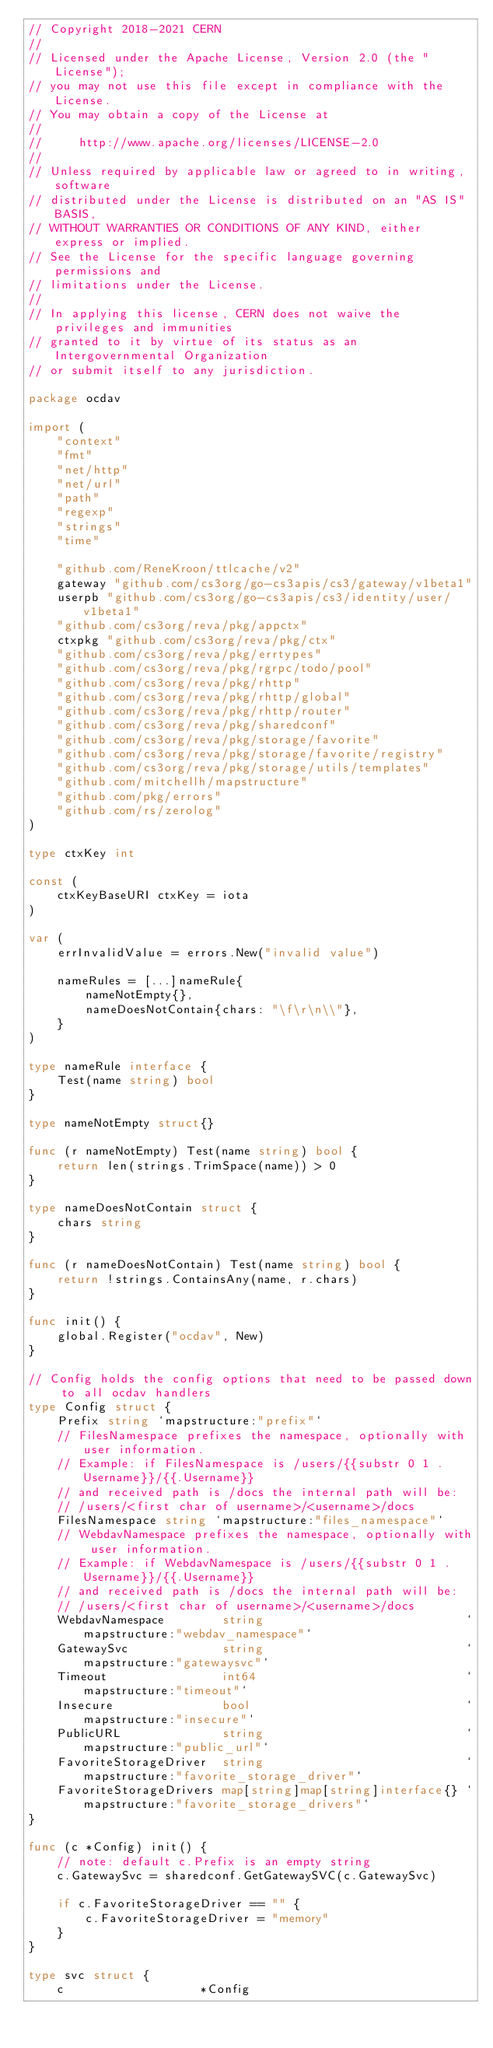<code> <loc_0><loc_0><loc_500><loc_500><_Go_>// Copyright 2018-2021 CERN
//
// Licensed under the Apache License, Version 2.0 (the "License");
// you may not use this file except in compliance with the License.
// You may obtain a copy of the License at
//
//     http://www.apache.org/licenses/LICENSE-2.0
//
// Unless required by applicable law or agreed to in writing, software
// distributed under the License is distributed on an "AS IS" BASIS,
// WITHOUT WARRANTIES OR CONDITIONS OF ANY KIND, either express or implied.
// See the License for the specific language governing permissions and
// limitations under the License.
//
// In applying this license, CERN does not waive the privileges and immunities
// granted to it by virtue of its status as an Intergovernmental Organization
// or submit itself to any jurisdiction.

package ocdav

import (
	"context"
	"fmt"
	"net/http"
	"net/url"
	"path"
	"regexp"
	"strings"
	"time"

	"github.com/ReneKroon/ttlcache/v2"
	gateway "github.com/cs3org/go-cs3apis/cs3/gateway/v1beta1"
	userpb "github.com/cs3org/go-cs3apis/cs3/identity/user/v1beta1"
	"github.com/cs3org/reva/pkg/appctx"
	ctxpkg "github.com/cs3org/reva/pkg/ctx"
	"github.com/cs3org/reva/pkg/errtypes"
	"github.com/cs3org/reva/pkg/rgrpc/todo/pool"
	"github.com/cs3org/reva/pkg/rhttp"
	"github.com/cs3org/reva/pkg/rhttp/global"
	"github.com/cs3org/reva/pkg/rhttp/router"
	"github.com/cs3org/reva/pkg/sharedconf"
	"github.com/cs3org/reva/pkg/storage/favorite"
	"github.com/cs3org/reva/pkg/storage/favorite/registry"
	"github.com/cs3org/reva/pkg/storage/utils/templates"
	"github.com/mitchellh/mapstructure"
	"github.com/pkg/errors"
	"github.com/rs/zerolog"
)

type ctxKey int

const (
	ctxKeyBaseURI ctxKey = iota
)

var (
	errInvalidValue = errors.New("invalid value")

	nameRules = [...]nameRule{
		nameNotEmpty{},
		nameDoesNotContain{chars: "\f\r\n\\"},
	}
)

type nameRule interface {
	Test(name string) bool
}

type nameNotEmpty struct{}

func (r nameNotEmpty) Test(name string) bool {
	return len(strings.TrimSpace(name)) > 0
}

type nameDoesNotContain struct {
	chars string
}

func (r nameDoesNotContain) Test(name string) bool {
	return !strings.ContainsAny(name, r.chars)
}

func init() {
	global.Register("ocdav", New)
}

// Config holds the config options that need to be passed down to all ocdav handlers
type Config struct {
	Prefix string `mapstructure:"prefix"`
	// FilesNamespace prefixes the namespace, optionally with user information.
	// Example: if FilesNamespace is /users/{{substr 0 1 .Username}}/{{.Username}}
	// and received path is /docs the internal path will be:
	// /users/<first char of username>/<username>/docs
	FilesNamespace string `mapstructure:"files_namespace"`
	// WebdavNamespace prefixes the namespace, optionally with user information.
	// Example: if WebdavNamespace is /users/{{substr 0 1 .Username}}/{{.Username}}
	// and received path is /docs the internal path will be:
	// /users/<first char of username>/<username>/docs
	WebdavNamespace        string                            `mapstructure:"webdav_namespace"`
	GatewaySvc             string                            `mapstructure:"gatewaysvc"`
	Timeout                int64                             `mapstructure:"timeout"`
	Insecure               bool                              `mapstructure:"insecure"`
	PublicURL              string                            `mapstructure:"public_url"`
	FavoriteStorageDriver  string                            `mapstructure:"favorite_storage_driver"`
	FavoriteStorageDrivers map[string]map[string]interface{} `mapstructure:"favorite_storage_drivers"`
}

func (c *Config) init() {
	// note: default c.Prefix is an empty string
	c.GatewaySvc = sharedconf.GetGatewaySVC(c.GatewaySvc)

	if c.FavoriteStorageDriver == "" {
		c.FavoriteStorageDriver = "memory"
	}
}

type svc struct {
	c                   *Config</code> 